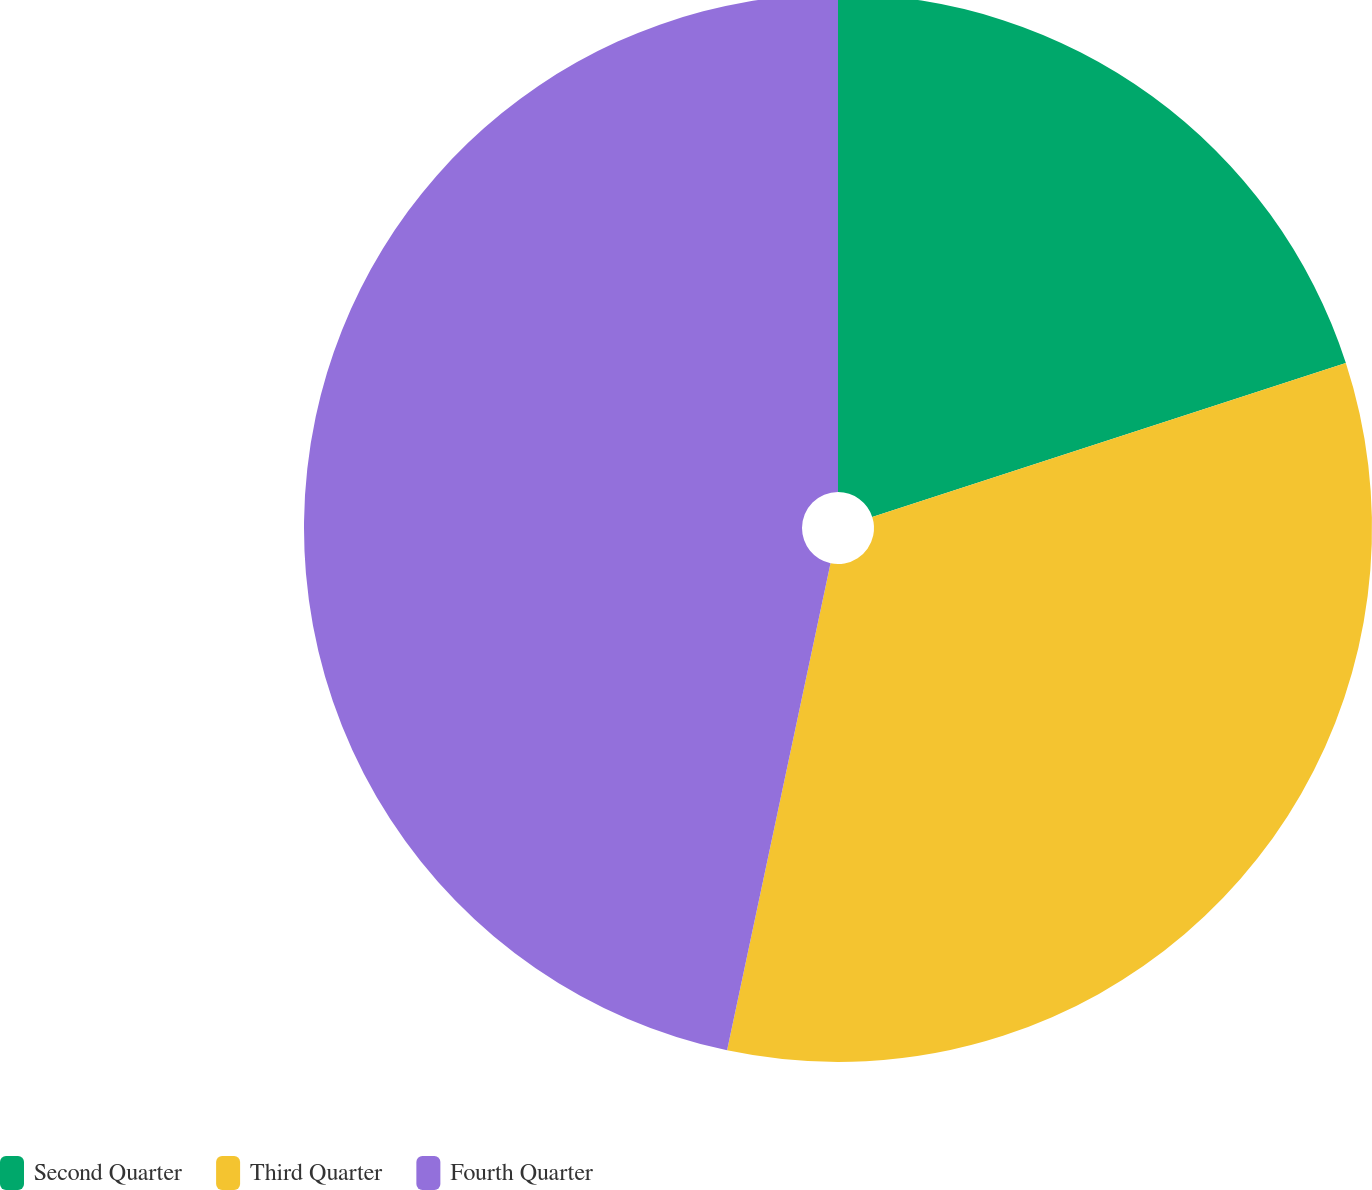Convert chart to OTSL. <chart><loc_0><loc_0><loc_500><loc_500><pie_chart><fcel>Second Quarter<fcel>Third Quarter<fcel>Fourth Quarter<nl><fcel>20.0%<fcel>33.33%<fcel>46.67%<nl></chart> 